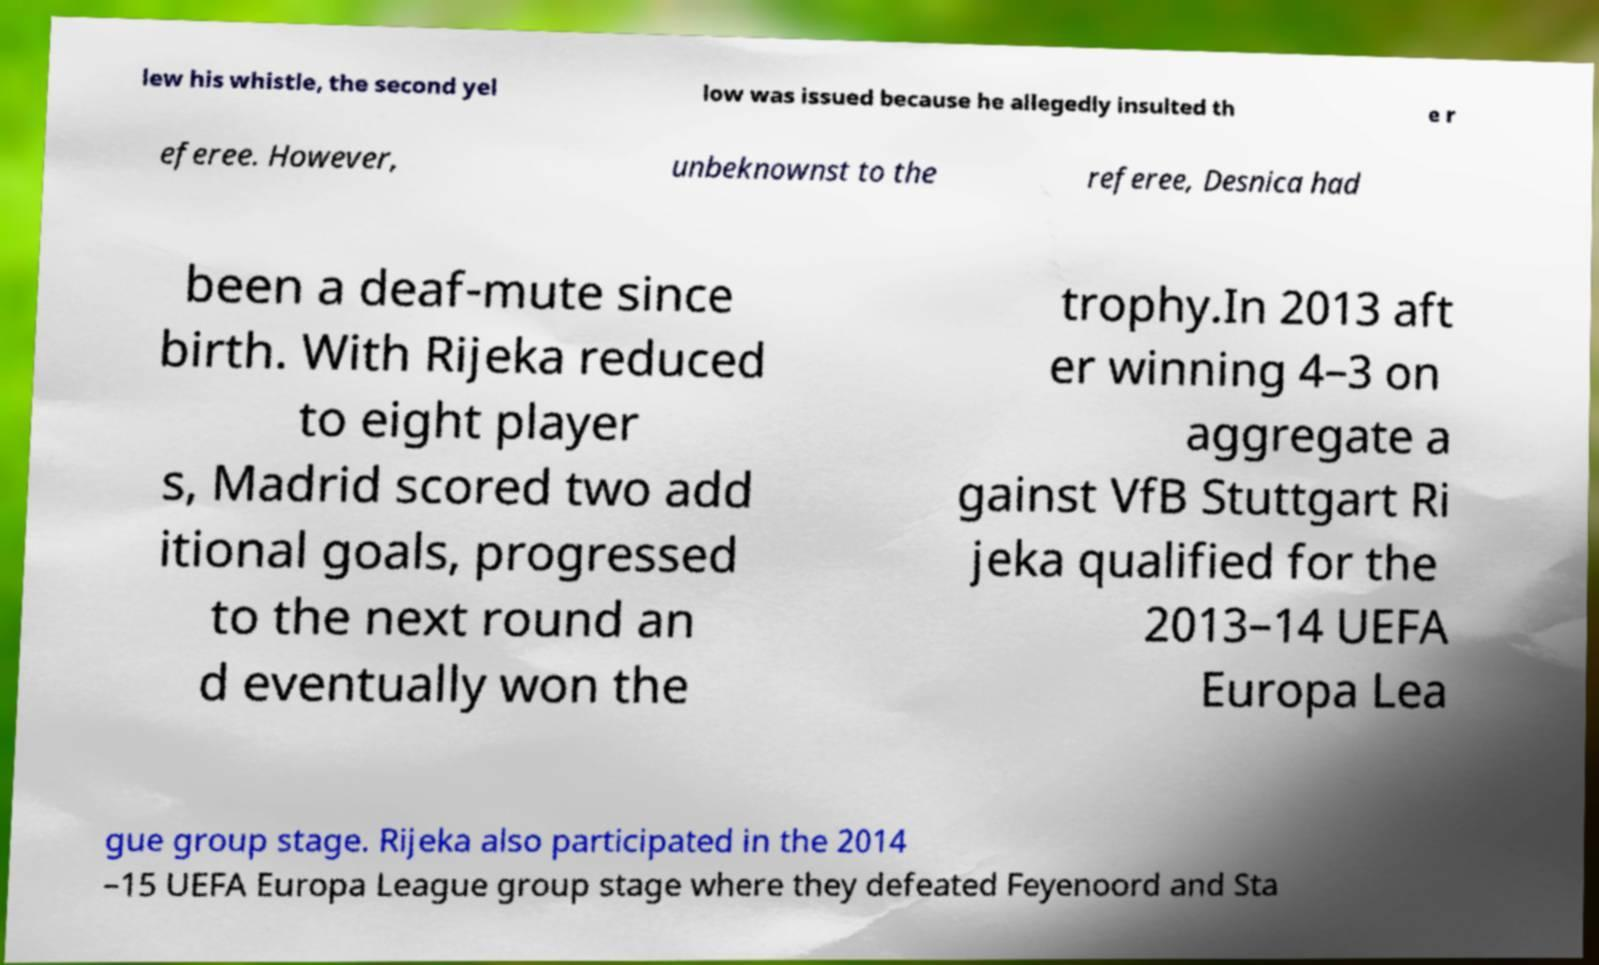Could you extract and type out the text from this image? lew his whistle, the second yel low was issued because he allegedly insulted th e r eferee. However, unbeknownst to the referee, Desnica had been a deaf-mute since birth. With Rijeka reduced to eight player s, Madrid scored two add itional goals, progressed to the next round an d eventually won the trophy.In 2013 aft er winning 4–3 on aggregate a gainst VfB Stuttgart Ri jeka qualified for the 2013–14 UEFA Europa Lea gue group stage. Rijeka also participated in the 2014 –15 UEFA Europa League group stage where they defeated Feyenoord and Sta 